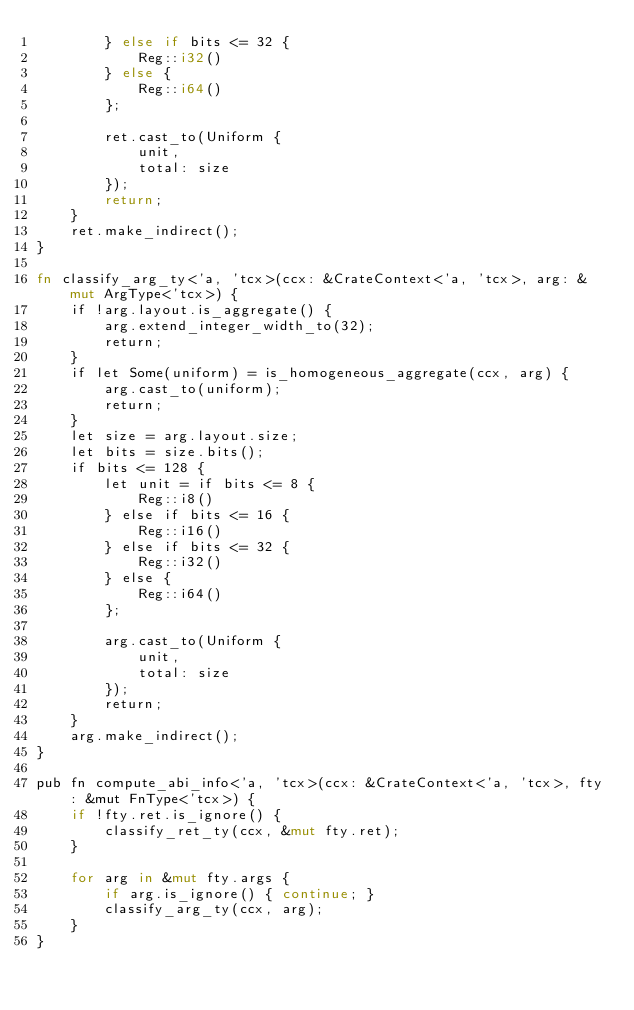<code> <loc_0><loc_0><loc_500><loc_500><_Rust_>        } else if bits <= 32 {
            Reg::i32()
        } else {
            Reg::i64()
        };

        ret.cast_to(Uniform {
            unit,
            total: size
        });
        return;
    }
    ret.make_indirect();
}

fn classify_arg_ty<'a, 'tcx>(ccx: &CrateContext<'a, 'tcx>, arg: &mut ArgType<'tcx>) {
    if !arg.layout.is_aggregate() {
        arg.extend_integer_width_to(32);
        return;
    }
    if let Some(uniform) = is_homogeneous_aggregate(ccx, arg) {
        arg.cast_to(uniform);
        return;
    }
    let size = arg.layout.size;
    let bits = size.bits();
    if bits <= 128 {
        let unit = if bits <= 8 {
            Reg::i8()
        } else if bits <= 16 {
            Reg::i16()
        } else if bits <= 32 {
            Reg::i32()
        } else {
            Reg::i64()
        };

        arg.cast_to(Uniform {
            unit,
            total: size
        });
        return;
    }
    arg.make_indirect();
}

pub fn compute_abi_info<'a, 'tcx>(ccx: &CrateContext<'a, 'tcx>, fty: &mut FnType<'tcx>) {
    if !fty.ret.is_ignore() {
        classify_ret_ty(ccx, &mut fty.ret);
    }

    for arg in &mut fty.args {
        if arg.is_ignore() { continue; }
        classify_arg_ty(ccx, arg);
    }
}
</code> 